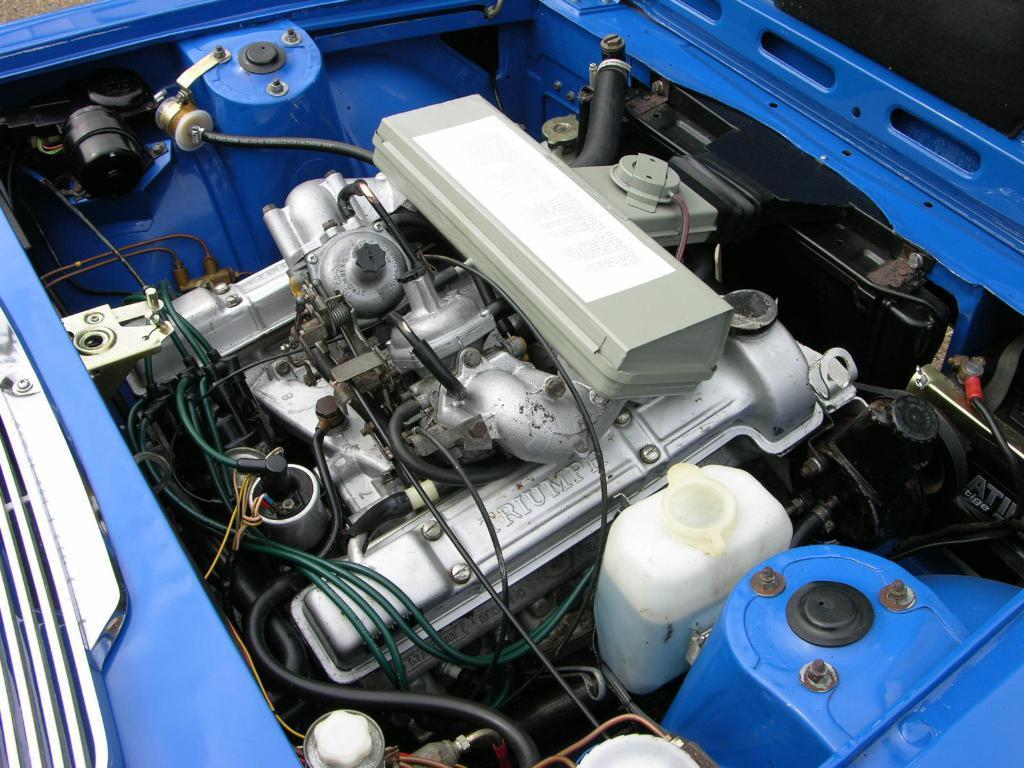How would you summarize this image in a sentence or two? In this image we can see there is a vehicle with open hood. 